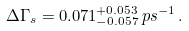<formula> <loc_0><loc_0><loc_500><loc_500>\Delta \Gamma _ { s } = 0 . 0 7 1 ^ { + 0 . 0 5 3 } _ { - 0 . 0 5 7 } \, p s ^ { - 1 } \, .</formula> 